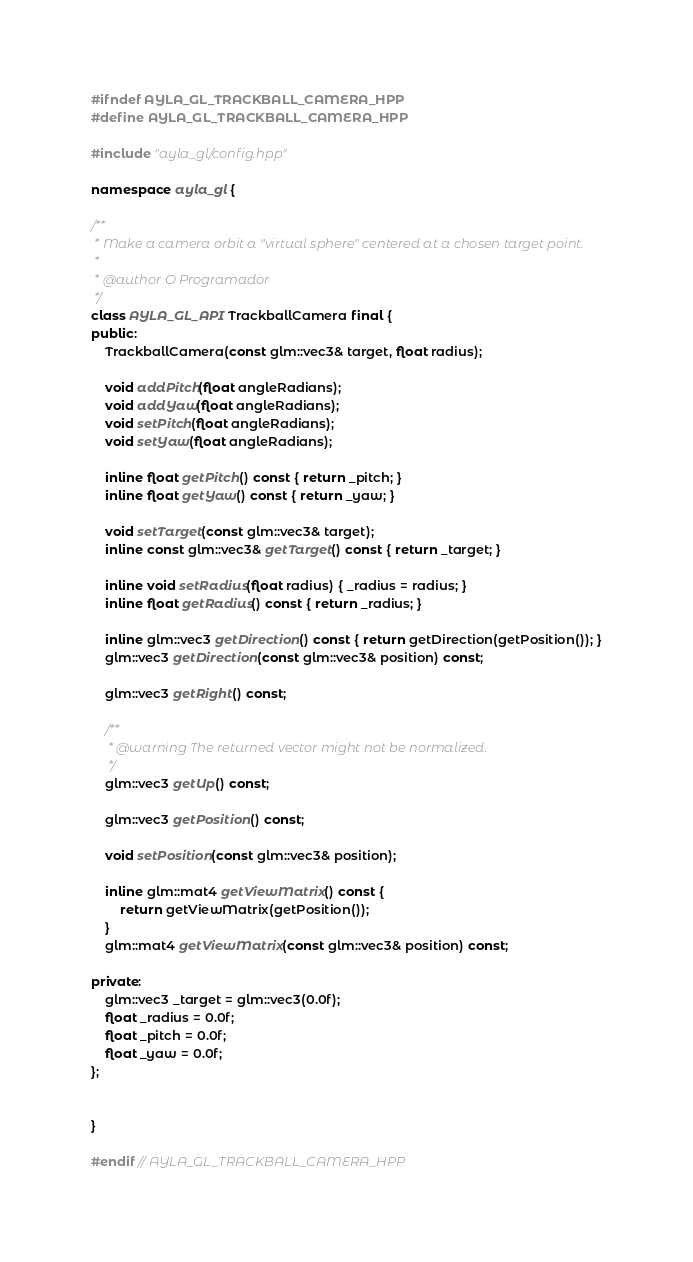Convert code to text. <code><loc_0><loc_0><loc_500><loc_500><_C++_>#ifndef AYLA_GL_TRACKBALL_CAMERA_HPP
#define AYLA_GL_TRACKBALL_CAMERA_HPP

#include "ayla_gl/config.hpp"

namespace ayla_gl {

/**
 * Make a camera orbit a "virtual sphere" centered at a chosen target point.
 *
 * @author O Programador
 */
class AYLA_GL_API TrackballCamera final {
public:
	TrackballCamera(const glm::vec3& target, float radius);

	void addPitch(float angleRadians);
	void addYaw(float angleRadians);
	void setPitch(float angleRadians);
	void setYaw(float angleRadians);

	inline float getPitch() const { return _pitch; }
	inline float getYaw() const { return _yaw; }

	void setTarget(const glm::vec3& target);
	inline const glm::vec3& getTarget() const { return _target; }
	
	inline void setRadius(float radius) { _radius = radius; }
	inline float getRadius() const { return _radius; }

	inline glm::vec3 getDirection() const { return getDirection(getPosition()); }
	glm::vec3 getDirection(const glm::vec3& position) const;

	glm::vec3 getRight() const;

	/**
	 * @warning The returned vector might not be normalized.
	 */
	glm::vec3 getUp() const;

	glm::vec3 getPosition() const;

	void setPosition(const glm::vec3& position);
	
	inline glm::mat4 getViewMatrix() const {
		return getViewMatrix(getPosition());
	}
	glm::mat4 getViewMatrix(const glm::vec3& position) const;

private:
	glm::vec3 _target = glm::vec3(0.0f);
	float _radius = 0.0f;
	float _pitch = 0.0f;
	float _yaw = 0.0f;
};


}

#endif // AYLA_GL_TRACKBALL_CAMERA_HPP</code> 